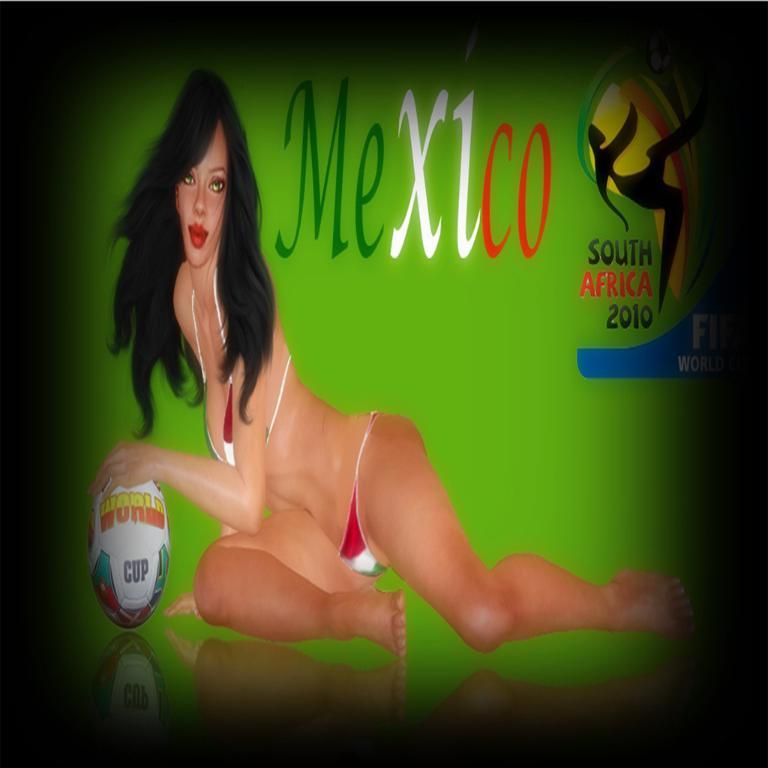What type of visual is the image? The image is a poster. What can be found on the poster besides visual elements? There is text written on the poster. Who or what is depicted on the poster? There is a woman and a ball depicted on the poster. Is there any branding or identification on the poster? Yes, there is a logo depicted on the poster. How does the crow get the attention of the woman depicted on the poster? There is no crow present in the image, so it cannot get the attention of the woman depicted on the poster. 